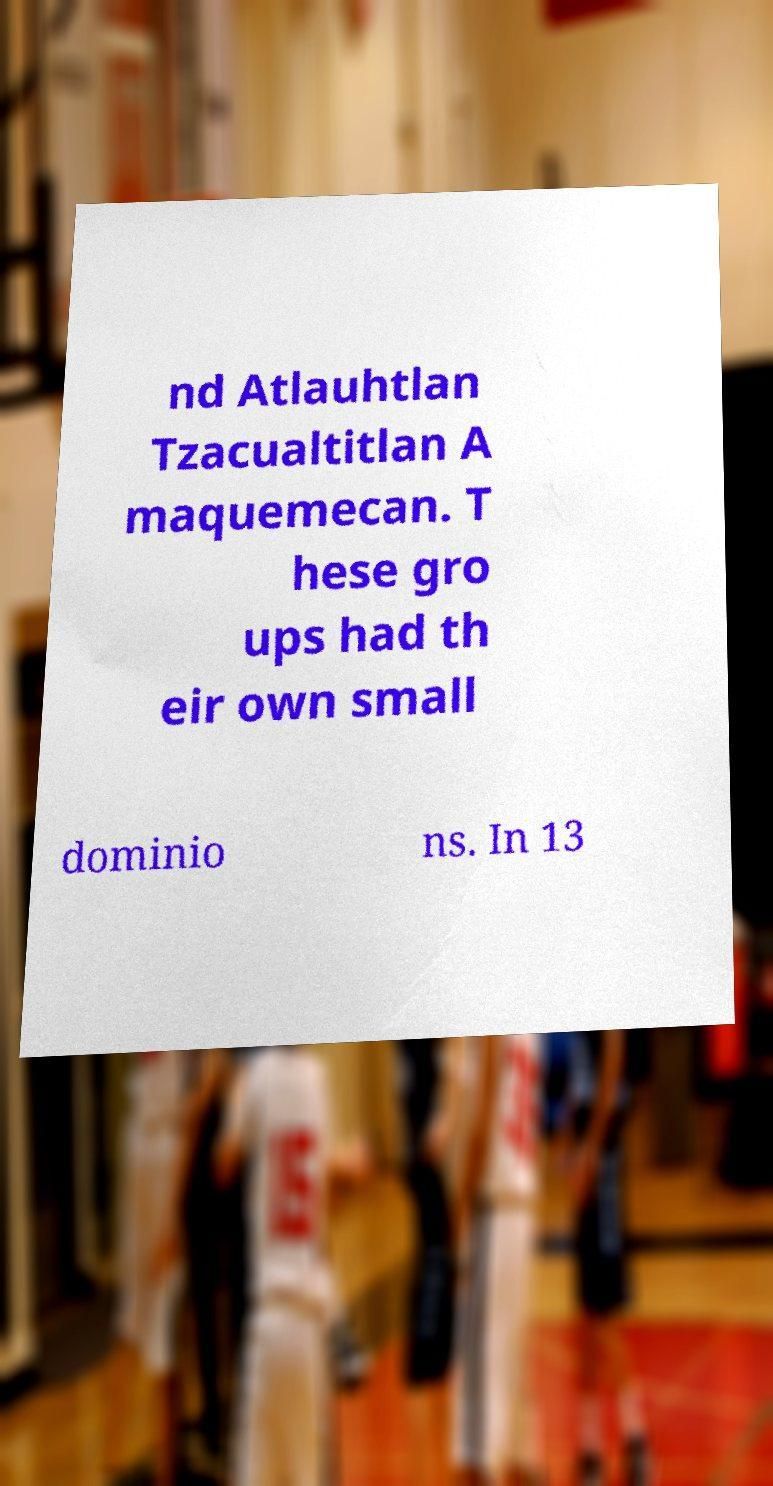I need the written content from this picture converted into text. Can you do that? nd Atlauhtlan Tzacualtitlan A maquemecan. T hese gro ups had th eir own small dominio ns. In 13 